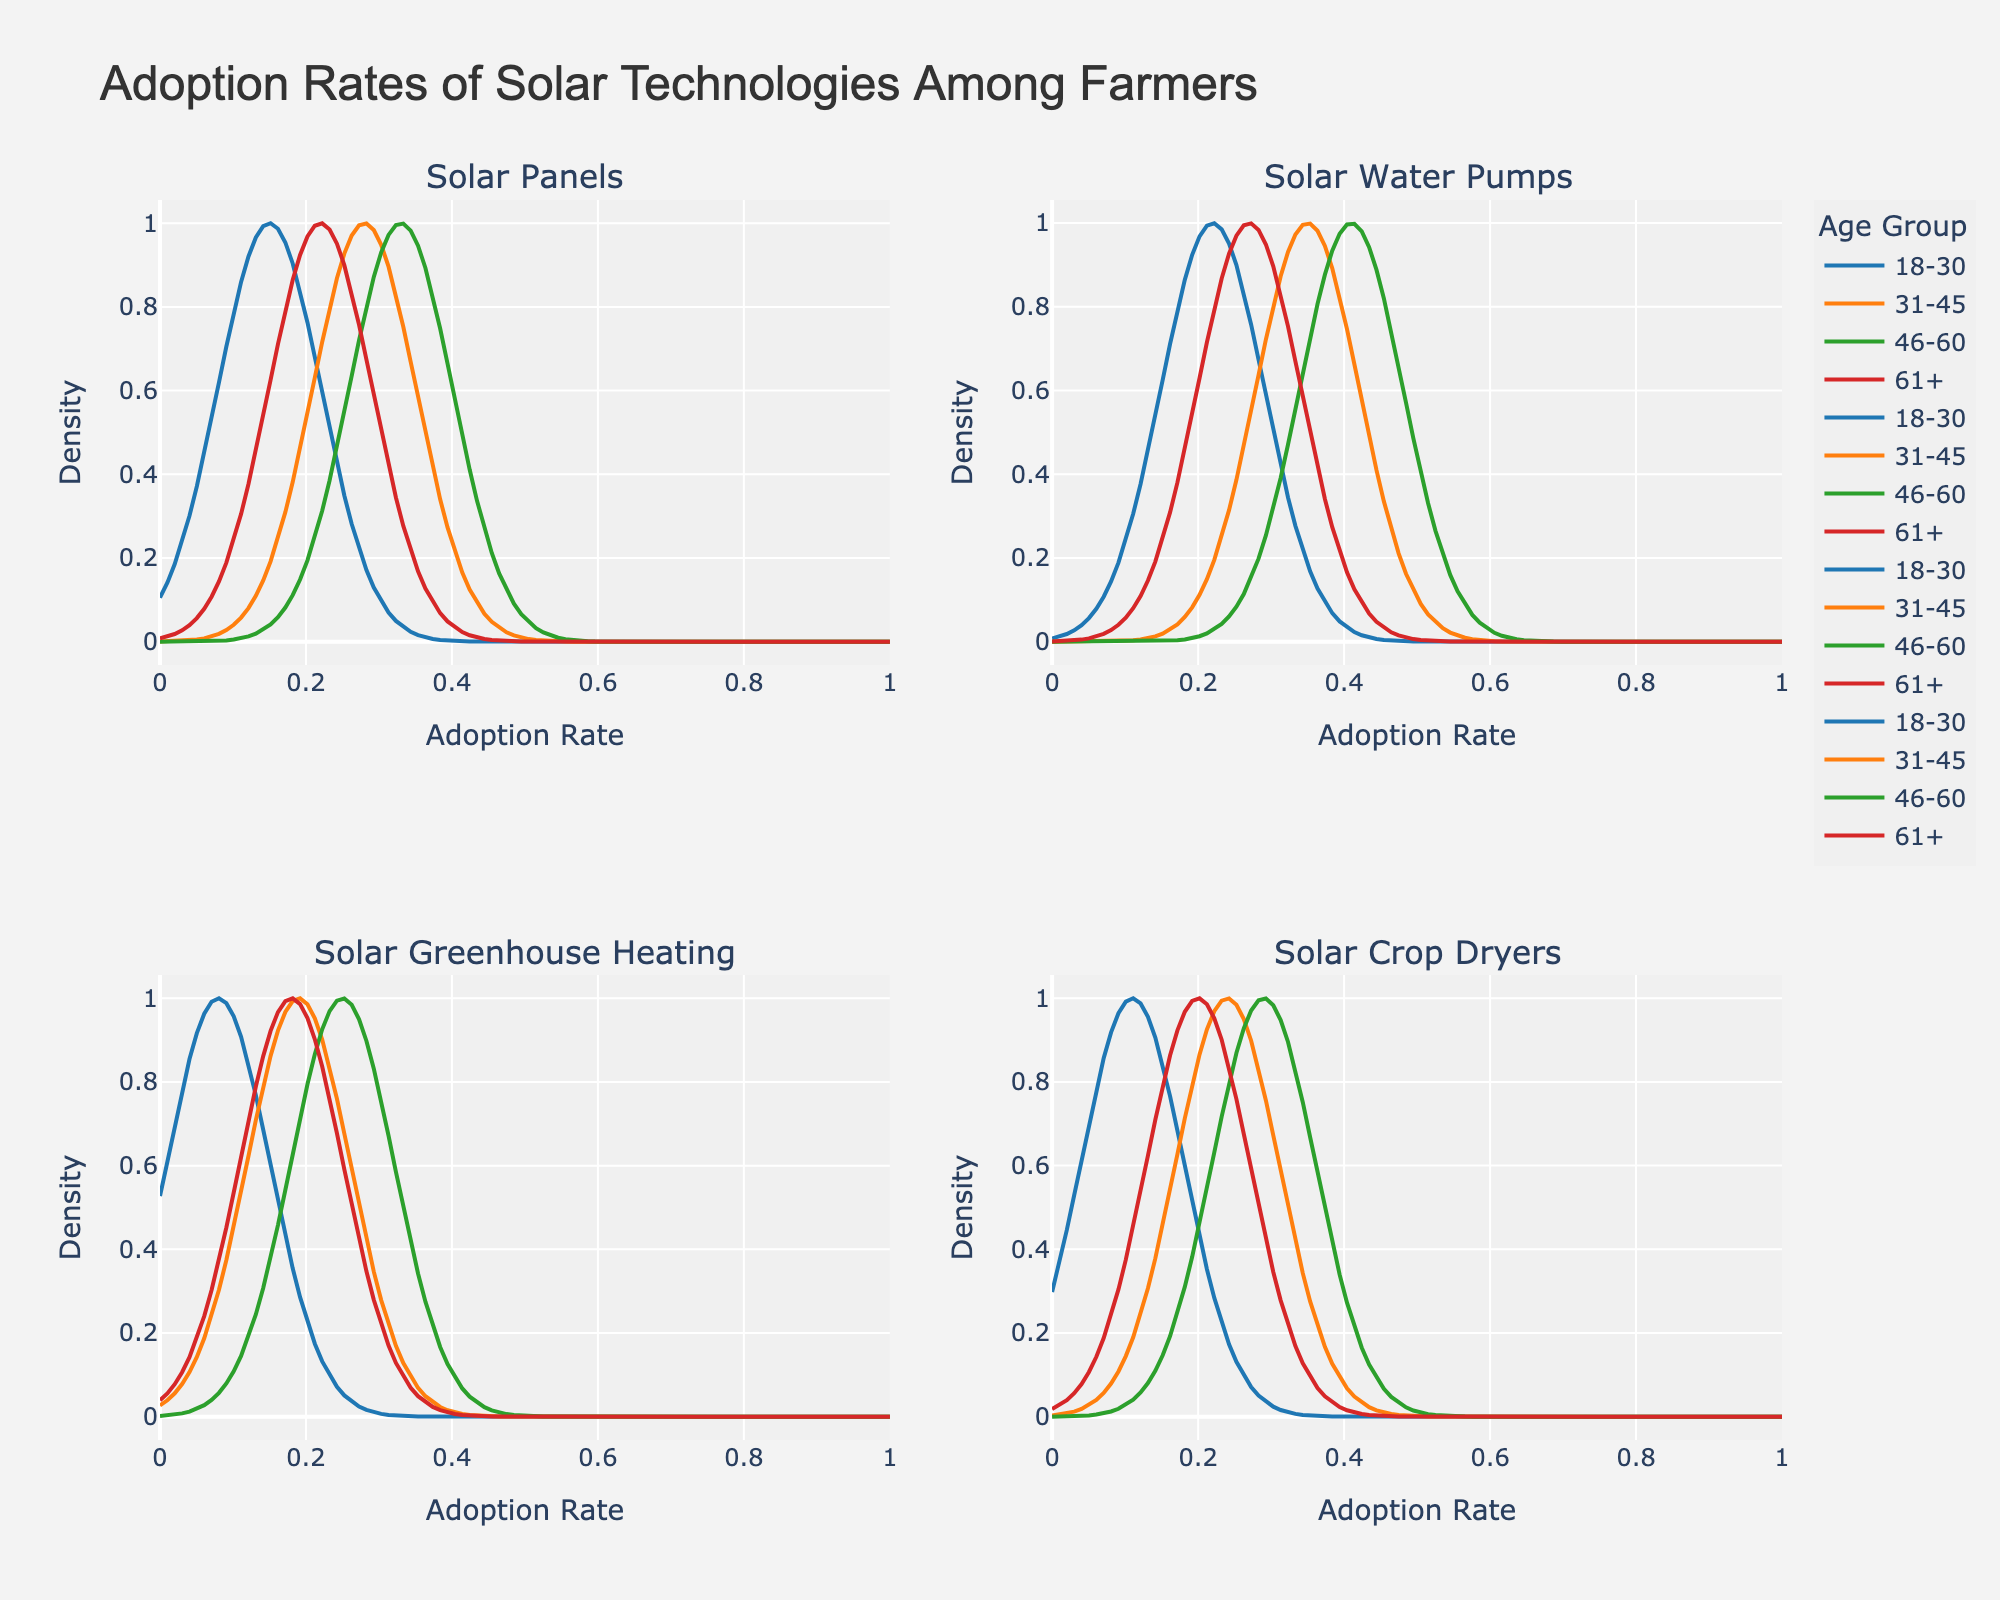What's the title of the figure? The title is displayed prominently at the top of the figure.
Answer: Adoption Rates of Solar Technologies Among Farmers Which age group has the highest density peak for Solar Water Pumps? Each subplot represents a different technology, with different colored lines indicating age groups. The highest peak for Solar Water Pumps is represented by the color associated with the age group 46-60.
Answer: 46-60 What is the adoption rate of Solar Crop Dryers for age group 31-45? The adoption rate can be read off from the position of the highest point of the curve for the Solar Crop Dryers subplot, corresponding to the color representing the age group 31-45.
Answer: 0.24 Among the technologies, which one has the lowest adoption rate for the age group 18-30? The subplot for each technology shows the densities for different age groups. For age group 18-30, the lowest density peak corresponds to Solar Greenhouse Heating.
Answer: Solar Greenhouse Heating What's the average adoption rate of Solar Panels across all age groups? The adoption rates can be summed up and divided by the number of age groups. (0.15 + 0.28 + 0.33 + 0.22) / 4 = 0.245
Answer: 0.245 Which technology has the most equal adoption rate distribution among the different age groups? By observing the density plots, the technology with the least variation in peak heights across all age groups is considered to have the most equal distribution. Solar Crop Dryers have relatively even peaks among all age groups.
Answer: Solar Crop Dryers Compare the adoption rates of Solar Greenhouse Heating between age groups 46-60 and 61+. Which is higher? The subplot for Solar Greenhouse Heating shows distinct peaks for different age groups. The peak for age group 46-60 is higher than that for 61+.
Answer: 46-60 In the Solar Panels subplot, which two age groups have the most similar adoption rates? By observing the positions of the peaks in the Solar Panels subplot, the age groups 18-30 and 61+ have the closest peak positions, indicating similar adoption rates.
Answer: 18-30 and 61+ Which age group shows the most significant increase in adoption rate when comparing Solar Panels to Solar Water Pumps? By comparing the heights of the peaks in the Solar Panels and Solar Water Pumps subplots, the age group 18-30 shows the largest increase in peak height.
Answer: 18-30 